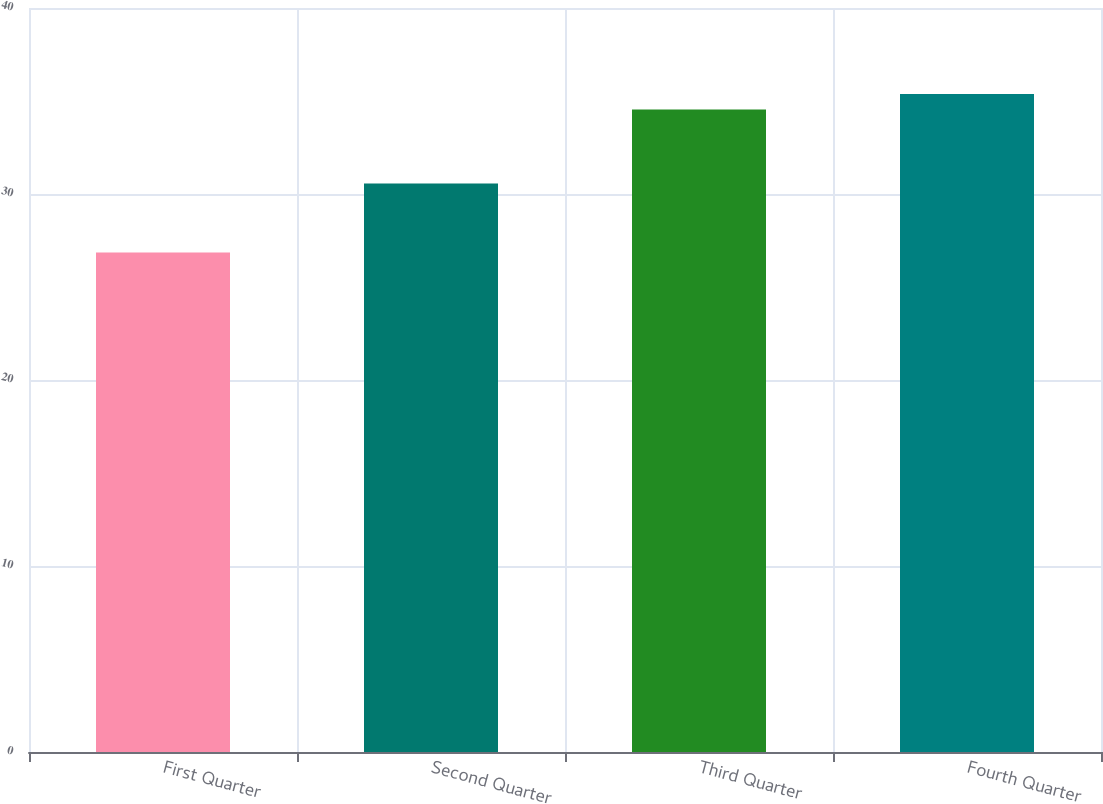<chart> <loc_0><loc_0><loc_500><loc_500><bar_chart><fcel>First Quarter<fcel>Second Quarter<fcel>Third Quarter<fcel>Fourth Quarter<nl><fcel>26.85<fcel>30.57<fcel>34.54<fcel>35.37<nl></chart> 